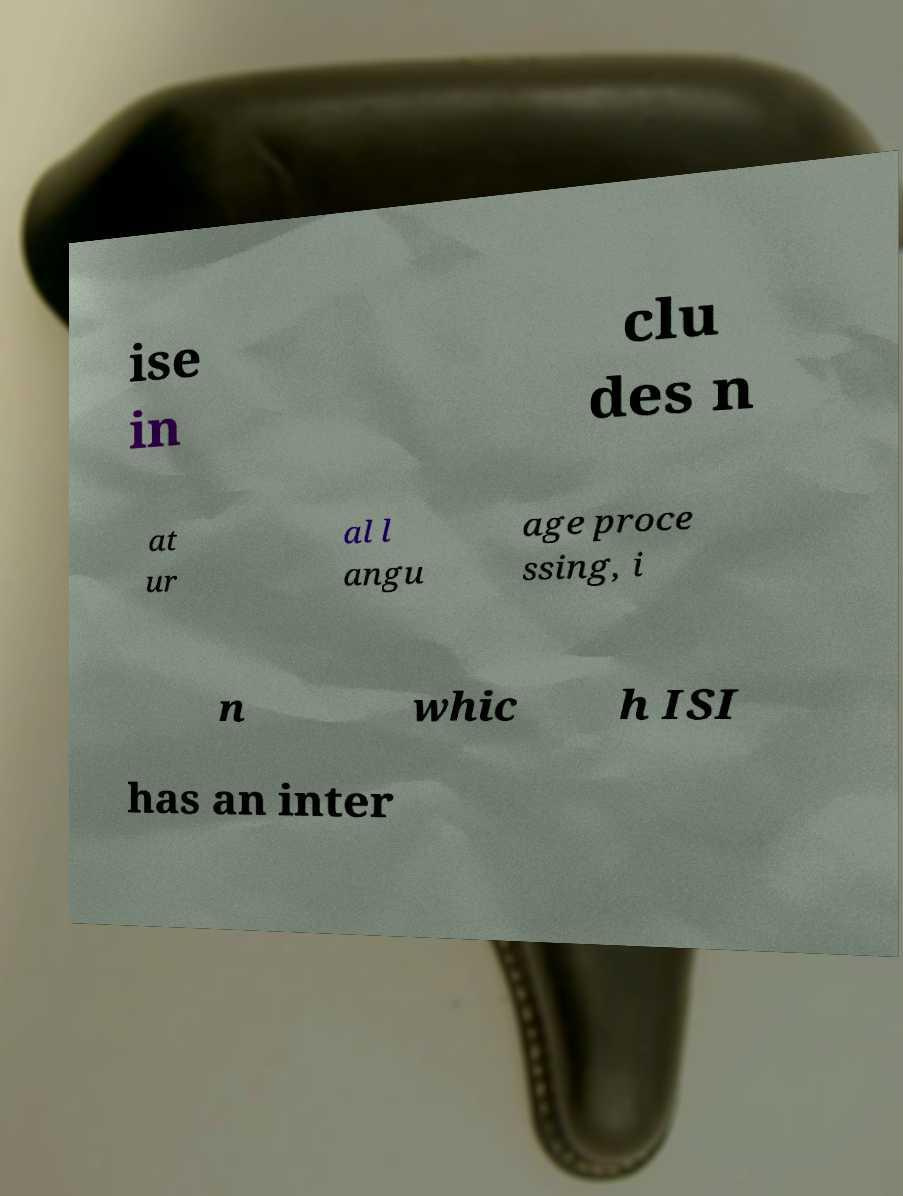For documentation purposes, I need the text within this image transcribed. Could you provide that? ise in clu des n at ur al l angu age proce ssing, i n whic h ISI has an inter 